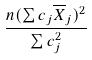Convert formula to latex. <formula><loc_0><loc_0><loc_500><loc_500>\frac { n ( \sum c _ { j } \overline { X } _ { j } ) ^ { 2 } } { \sum c _ { j } ^ { 2 } }</formula> 